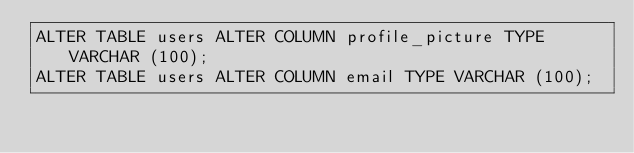<code> <loc_0><loc_0><loc_500><loc_500><_SQL_>ALTER TABLE users ALTER COLUMN profile_picture TYPE VARCHAR (100);
ALTER TABLE users ALTER COLUMN email TYPE VARCHAR (100);
</code> 